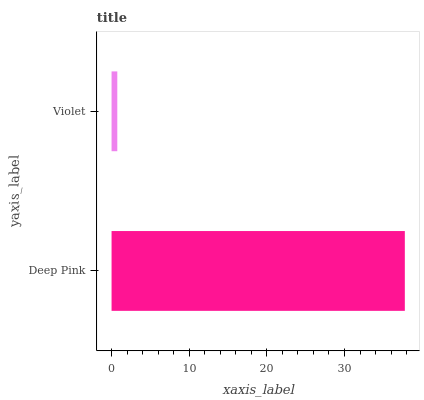Is Violet the minimum?
Answer yes or no. Yes. Is Deep Pink the maximum?
Answer yes or no. Yes. Is Violet the maximum?
Answer yes or no. No. Is Deep Pink greater than Violet?
Answer yes or no. Yes. Is Violet less than Deep Pink?
Answer yes or no. Yes. Is Violet greater than Deep Pink?
Answer yes or no. No. Is Deep Pink less than Violet?
Answer yes or no. No. Is Deep Pink the high median?
Answer yes or no. Yes. Is Violet the low median?
Answer yes or no. Yes. Is Violet the high median?
Answer yes or no. No. Is Deep Pink the low median?
Answer yes or no. No. 